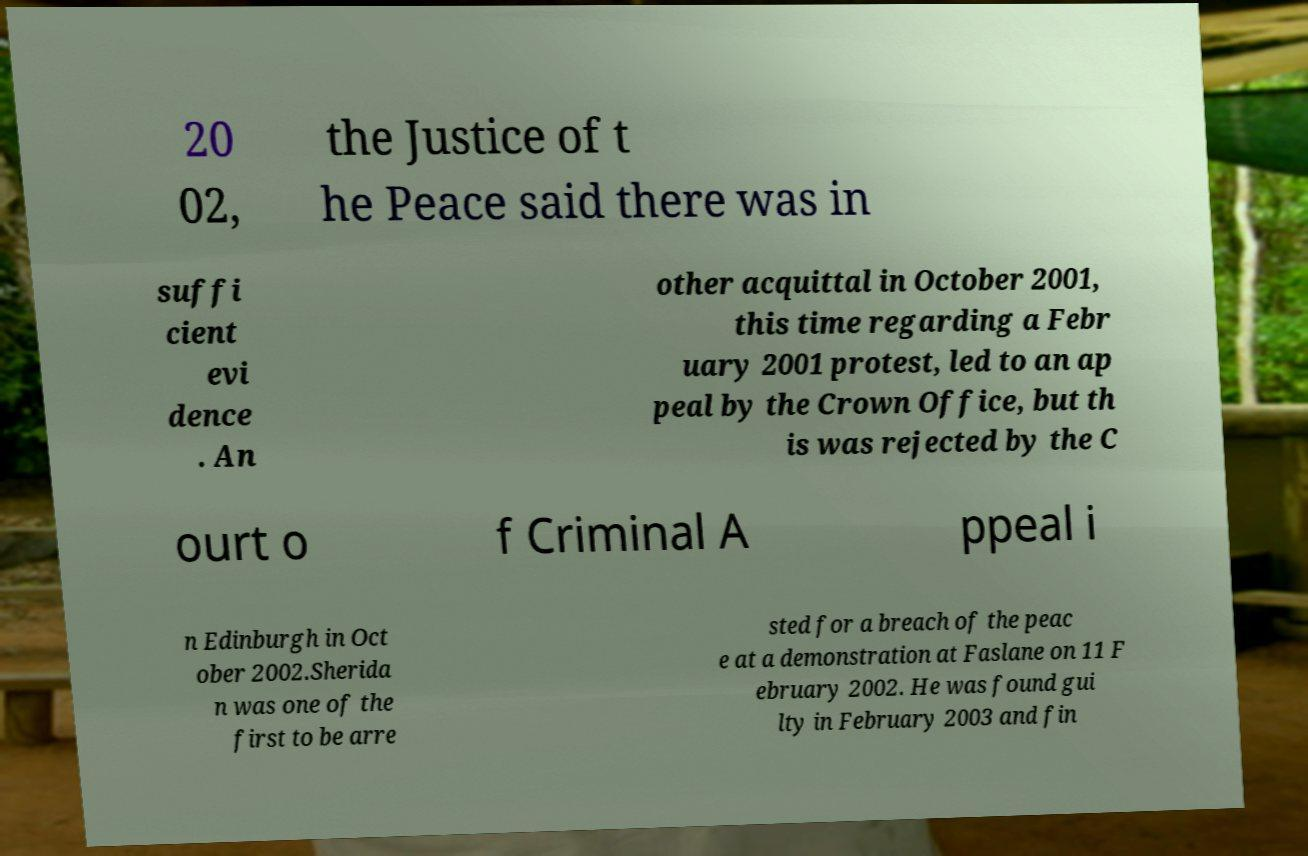Can you accurately transcribe the text from the provided image for me? 20 02, the Justice of t he Peace said there was in suffi cient evi dence . An other acquittal in October 2001, this time regarding a Febr uary 2001 protest, led to an ap peal by the Crown Office, but th is was rejected by the C ourt o f Criminal A ppeal i n Edinburgh in Oct ober 2002.Sherida n was one of the first to be arre sted for a breach of the peac e at a demonstration at Faslane on 11 F ebruary 2002. He was found gui lty in February 2003 and fin 